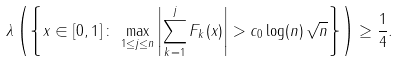Convert formula to latex. <formula><loc_0><loc_0><loc_500><loc_500>\lambda \left ( \left \{ x \in [ 0 , 1 ] \, \colon \, \max _ { 1 \leq j \leq n } \left | \sum _ { k = 1 } ^ { j } F _ { k } ( x ) \right | > c _ { 0 } \log ( n ) \, \sqrt { n } \right \} \right ) \geq \frac { 1 } { 4 } .</formula> 